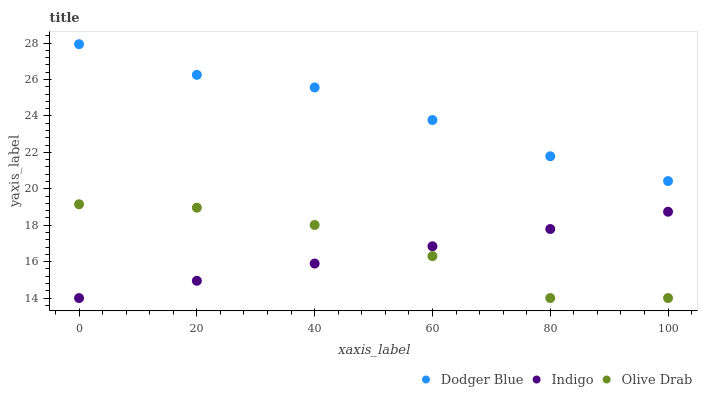Does Indigo have the minimum area under the curve?
Answer yes or no. Yes. Does Dodger Blue have the maximum area under the curve?
Answer yes or no. Yes. Does Olive Drab have the minimum area under the curve?
Answer yes or no. No. Does Olive Drab have the maximum area under the curve?
Answer yes or no. No. Is Indigo the smoothest?
Answer yes or no. Yes. Is Olive Drab the roughest?
Answer yes or no. Yes. Is Dodger Blue the smoothest?
Answer yes or no. No. Is Dodger Blue the roughest?
Answer yes or no. No. Does Indigo have the lowest value?
Answer yes or no. Yes. Does Dodger Blue have the lowest value?
Answer yes or no. No. Does Dodger Blue have the highest value?
Answer yes or no. Yes. Does Olive Drab have the highest value?
Answer yes or no. No. Is Olive Drab less than Dodger Blue?
Answer yes or no. Yes. Is Dodger Blue greater than Indigo?
Answer yes or no. Yes. Does Olive Drab intersect Indigo?
Answer yes or no. Yes. Is Olive Drab less than Indigo?
Answer yes or no. No. Is Olive Drab greater than Indigo?
Answer yes or no. No. Does Olive Drab intersect Dodger Blue?
Answer yes or no. No. 